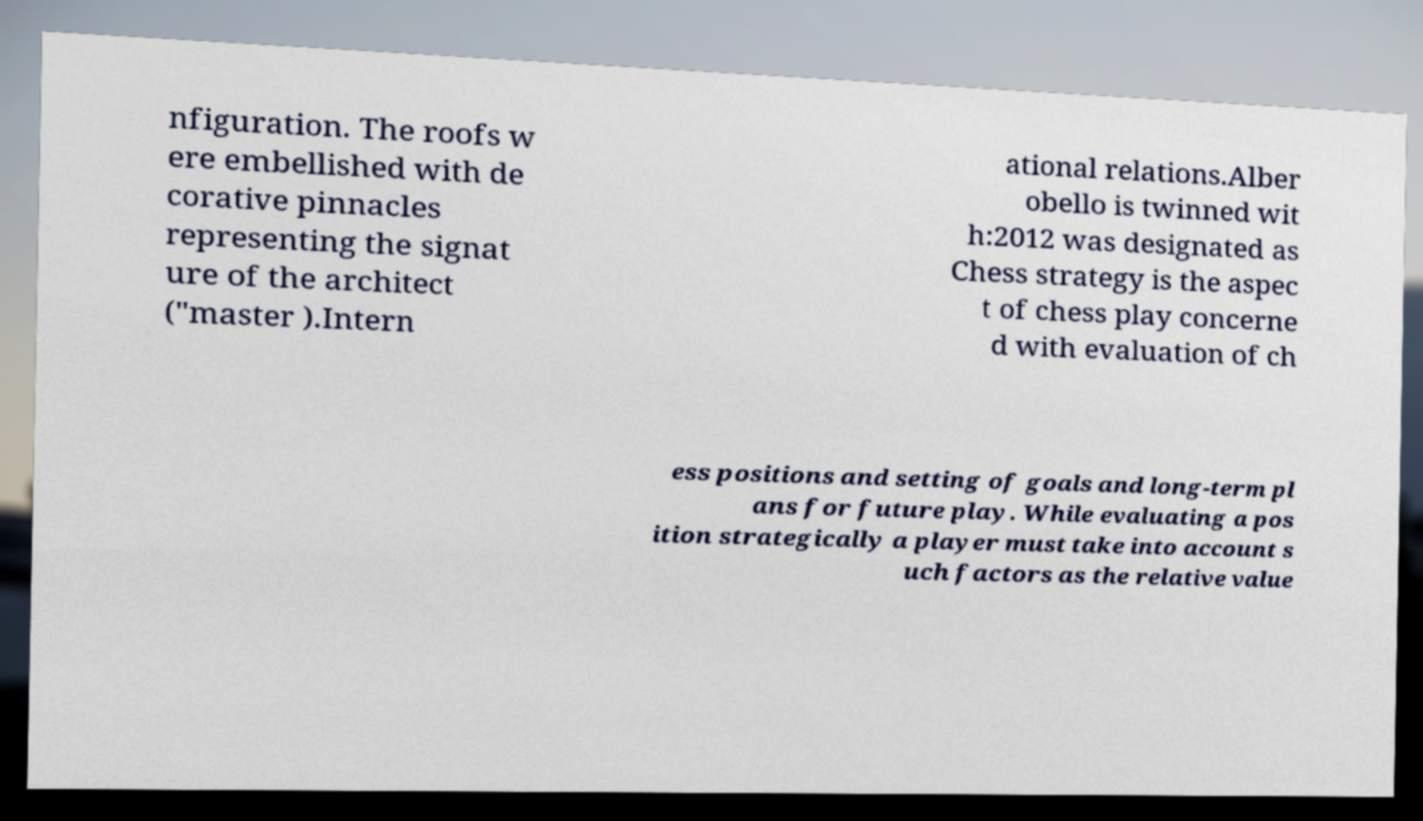Could you assist in decoding the text presented in this image and type it out clearly? nfiguration. The roofs w ere embellished with de corative pinnacles representing the signat ure of the architect ("master ).Intern ational relations.Alber obello is twinned wit h:2012 was designated as Chess strategy is the aspec t of chess play concerne d with evaluation of ch ess positions and setting of goals and long-term pl ans for future play. While evaluating a pos ition strategically a player must take into account s uch factors as the relative value 